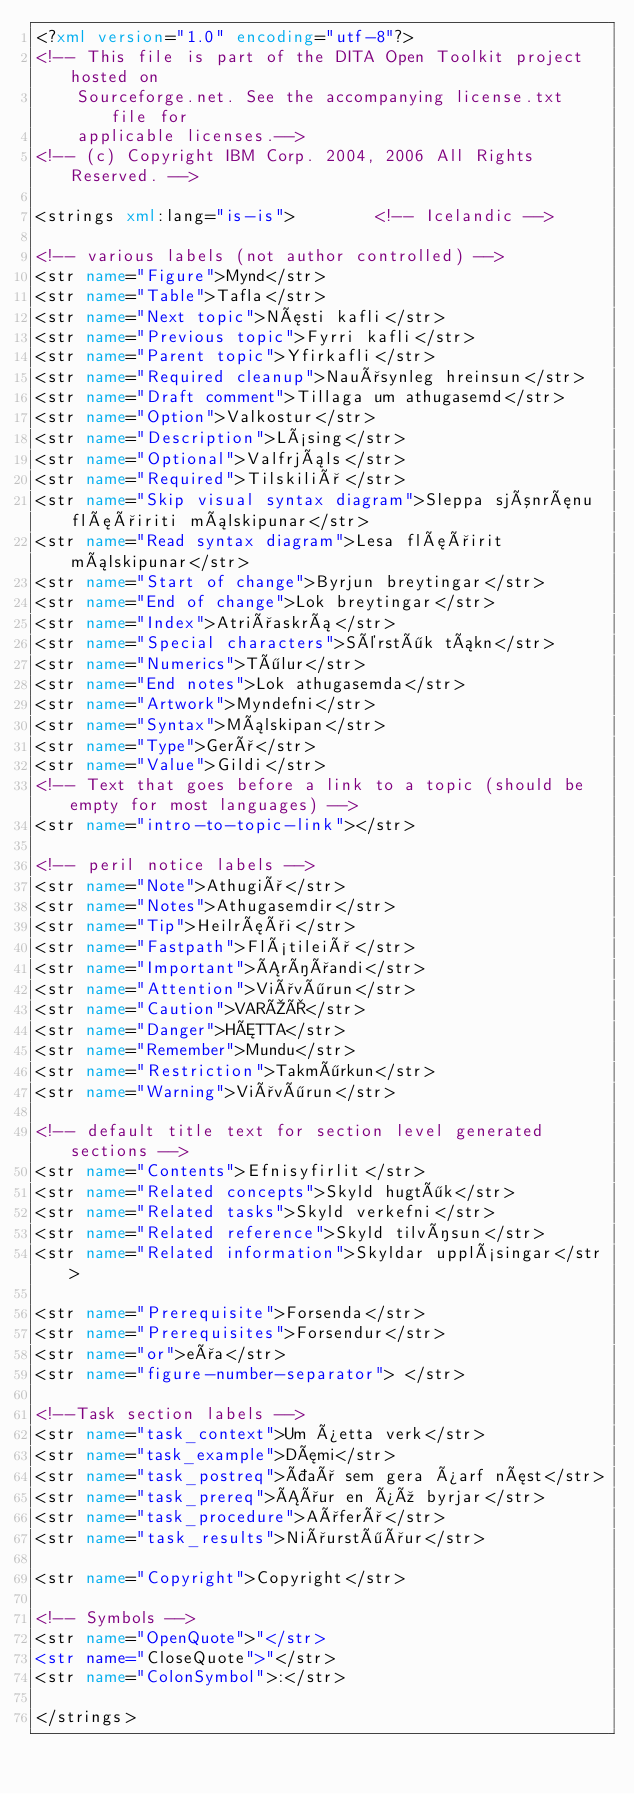Convert code to text. <code><loc_0><loc_0><loc_500><loc_500><_XML_><?xml version="1.0" encoding="utf-8"?>
<!-- This file is part of the DITA Open Toolkit project hosted on 
    Sourceforge.net. See the accompanying license.txt file for 
    applicable licenses.-->
<!-- (c) Copyright IBM Corp. 2004, 2006 All Rights Reserved. -->

<strings xml:lang="is-is">        <!-- Icelandic -->

<!-- various labels (not author controlled) -->
<str name="Figure">Mynd</str>
<str name="Table">Tafla</str>
<str name="Next topic">Næsti kafli</str>
<str name="Previous topic">Fyrri kafli</str>
<str name="Parent topic">Yfirkafli</str>
<str name="Required cleanup">Nauðsynleg hreinsun</str>
<str name="Draft comment">Tillaga um athugasemd</str>
<str name="Option">Valkostur</str>
<str name="Description">Lýsing</str>
<str name="Optional">Valfrjáls</str>
<str name="Required">Tilskilið</str>
<str name="Skip visual syntax diagram">Sleppa sjónrænu flæðiriti málskipunar</str>
<str name="Read syntax diagram">Lesa flæðirit málskipunar</str>
<str name="Start of change">Byrjun breytingar</str>
<str name="End of change">Lok breytingar</str>
<str name="Index">Atriðaskrá</str>
<str name="Special characters">Sérstök tákn</str>
<str name="Numerics">Tölur</str>
<str name="End notes">Lok athugasemda</str>
<str name="Artwork">Myndefni</str>
<str name="Syntax">Málskipan</str>
<str name="Type">Gerð</str>
<str name="Value">Gildi</str>
<!-- Text that goes before a link to a topic (should be empty for most languages) -->
<str name="intro-to-topic-link"></str>

<!-- peril notice labels -->
<str name="Note">Athugið</str>
<str name="Notes">Athugasemdir</str>
<str name="Tip">Heilræði</str>
<str name="Fastpath">Flýtileið</str>
<str name="Important">Áríðandi</str>
<str name="Attention">Viðvörun</str>
<str name="Caution">VARÚÐ</str>
<str name="Danger">HÆTTA</str>
<str name="Remember">Mundu</str>
<str name="Restriction">Takmörkun</str>
<str name="Warning">Viðvörun</str>

<!-- default title text for section level generated sections -->
<str name="Contents">Efnisyfirlit</str>
<str name="Related concepts">Skyld hugtök</str>
<str name="Related tasks">Skyld verkefni</str>
<str name="Related reference">Skyld tilvísun</str>
<str name="Related information">Skyldar upplýsingar</str>

<str name="Prerequisite">Forsenda</str>
<str name="Prerequisites">Forsendur</str>
<str name="or">eða</str>
<str name="figure-number-separator"> </str>

<!--Task section labels -->
<str name="task_context">Um þetta verk</str>
<str name="task_example">Dæmi</str>
<str name="task_postreq">Það sem gera þarf næst</str>
<str name="task_prereq">Áður en þú byrjar</str>
<str name="task_procedure">Aðferð</str>
<str name="task_results">Niðurstöður</str>

<str name="Copyright">Copyright</str>

<!-- Symbols -->
<str name="OpenQuote">"</str>
<str name="CloseQuote">"</str>
<str name="ColonSymbol">:</str>

</strings>
</code> 